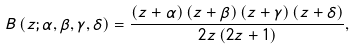Convert formula to latex. <formula><loc_0><loc_0><loc_500><loc_500>B \left ( z ; \alpha , \beta , \gamma , \delta \right ) = \frac { \left ( z + \alpha \right ) \left ( z + \beta \right ) \left ( z + \gamma \right ) \left ( z + \delta \right ) } { 2 z \left ( 2 z + 1 \right ) } ,</formula> 